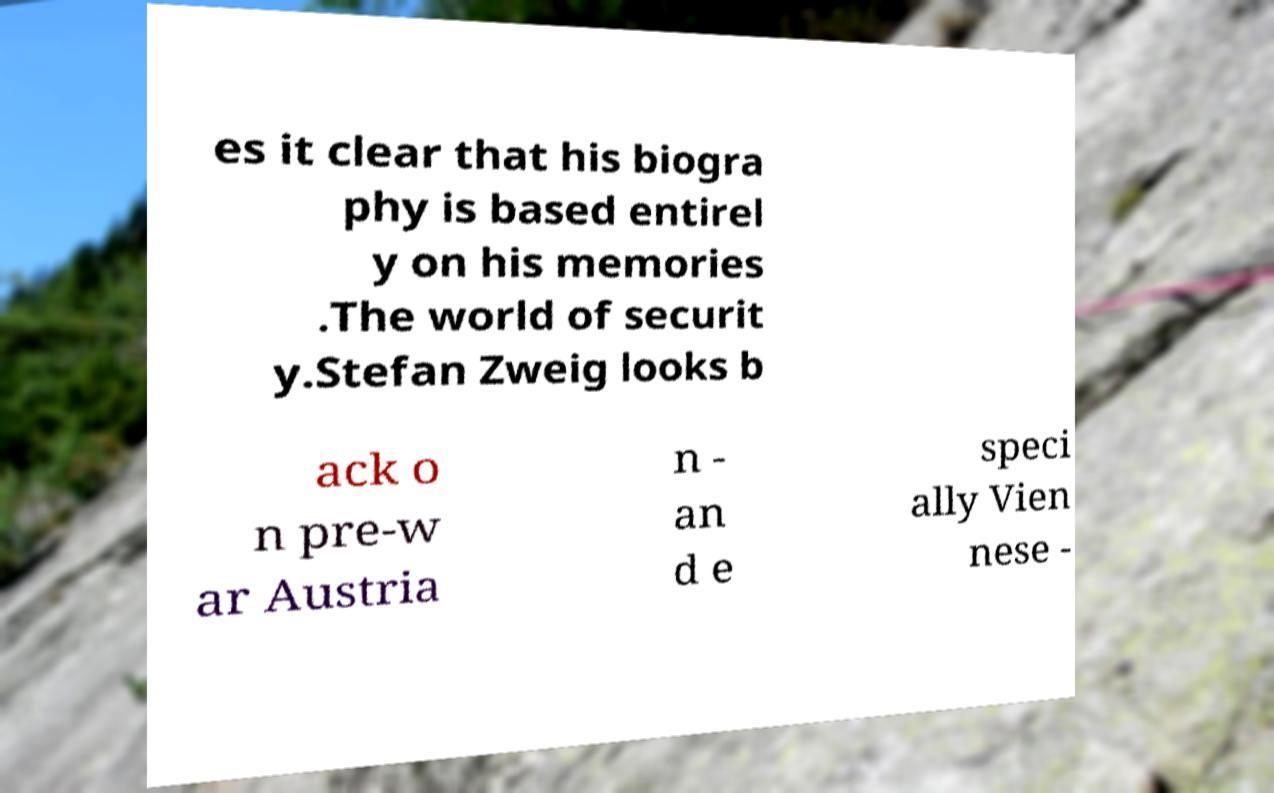I need the written content from this picture converted into text. Can you do that? es it clear that his biogra phy is based entirel y on his memories .The world of securit y.Stefan Zweig looks b ack o n pre-w ar Austria n - an d e speci ally Vien nese - 